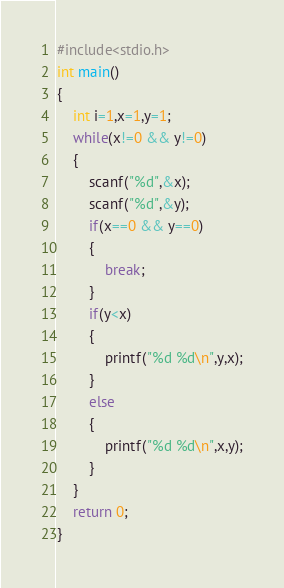Convert code to text. <code><loc_0><loc_0><loc_500><loc_500><_C_>#include<stdio.h>
int main()
{
	int i=1,x=1,y=1;
	while(x!=0 && y!=0)
	{
		scanf("%d",&x);
		scanf("%d",&y);
		if(x==0 && y==0)
		{
			break;
		}
		if(y<x)
		{
			printf("%d %d\n",y,x);
		}
		else
		{
			printf("%d %d\n",x,y);
		}
	}
	return 0;
}</code> 